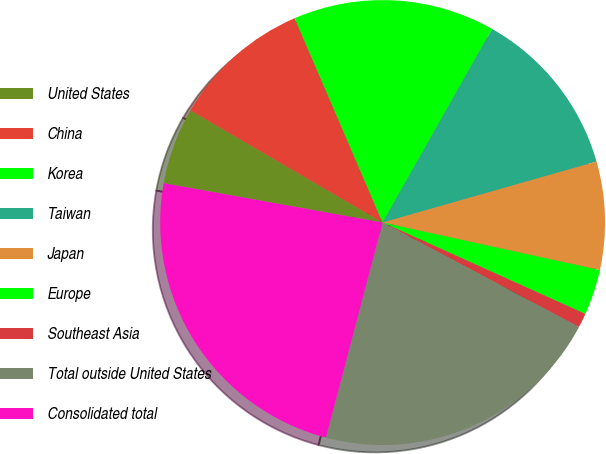Convert chart. <chart><loc_0><loc_0><loc_500><loc_500><pie_chart><fcel>United States<fcel>China<fcel>Korea<fcel>Taiwan<fcel>Japan<fcel>Europe<fcel>Southeast Asia<fcel>Total outside United States<fcel>Consolidated total<nl><fcel>5.58%<fcel>10.12%<fcel>14.66%<fcel>12.39%<fcel>7.85%<fcel>3.31%<fcel>1.04%<fcel>21.32%<fcel>23.73%<nl></chart> 